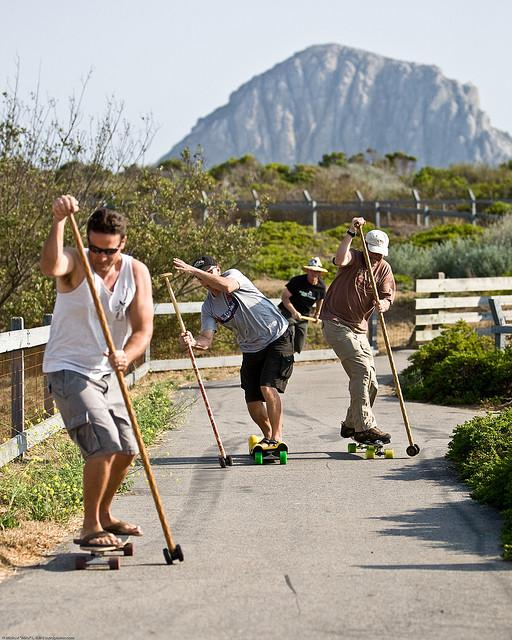What are the men doing with the large wooden poles?

Choices:
A) exercising
B) fighting
C) land paddling
D) jousting land paddling 